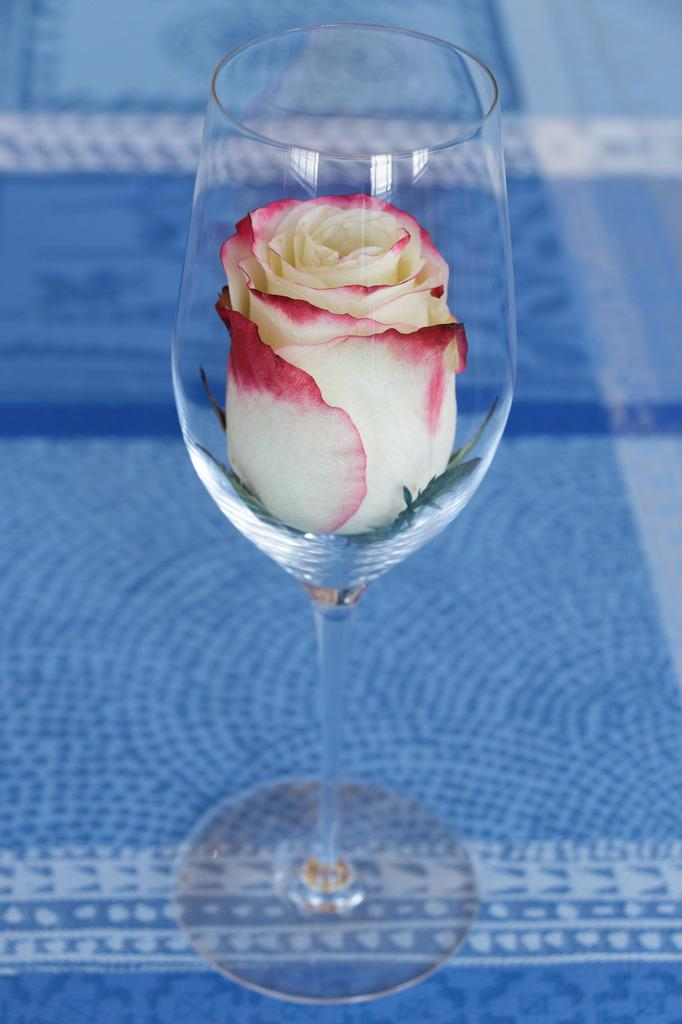What is the main object in the center of the picture? There is a glass in the center of the picture. What is inside the glass? A rose flower is inside the glass. What is the glass placed on? The glass is placed on a blue color cloth. How many letters are visible on the blue cloth in the image? There are no letters visible on the blue cloth in the image. Can you see any snails crawling on the rose flower in the glass? There are no snails present in the image. 